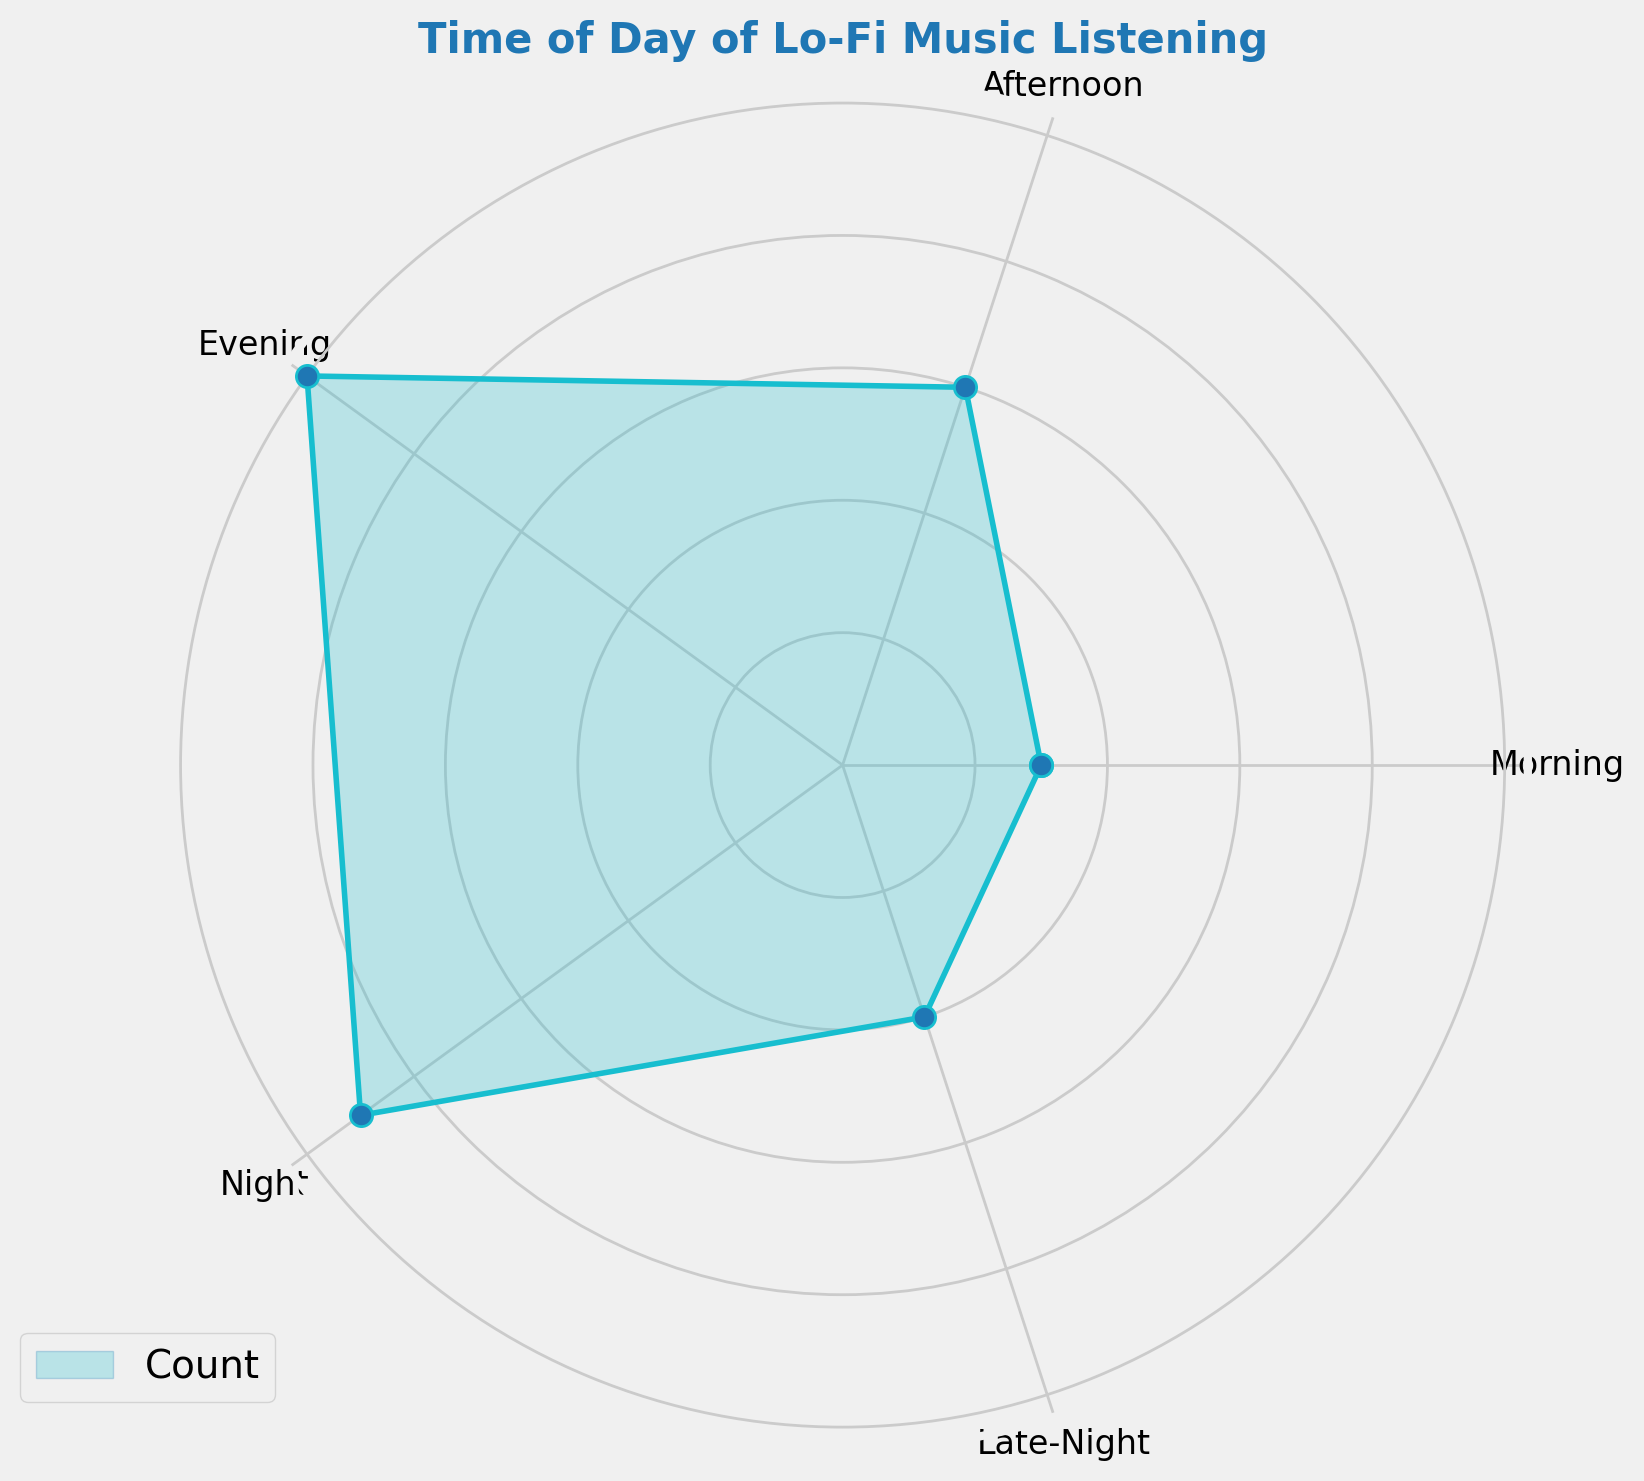What time of day has the highest count of lo-fi music listening? To determine this, observe the radar chart and note where the value reaches its highest point. The highest count is where the data point is farthest from the center. In this case, it's during the Evening.
Answer: Evening Which two time periods have similar listening counts? Look for time periods where the data points are at similar distances from the center. In this case, the Night and Evening sections both have high counts, with Night having a slightly lower count than Evening.
Answer: Night and Evening What is the total count of lo-fi music listening during Morning and Late-Night combined? Add up the counts for Morning and Late-Night. The Morning count is 150 and Late-Night is 200. So, 150 + 200 = 350.
Answer: 350 What is the difference in the count of lo-fi music listening between Afternoon and Night? Subtract the count for Afternoon from the count for Night. Afternoon is 300 and Night is 450. So, 450 - 300 = 150.
Answer: 150 How does the listening count in the Morning compare to that in the Late-Night? Compare the distances from the center for Morning and Late-Night. Morning (150) is shorter than Late-Night (200).
Answer: Morning < Late-Night Which period has the second lowest count of lo-fi music listening? Identify the second smallest value among the displayed counts. The lowest is Morning at 150, and the second lowest is Late-Night at 200.
Answer: Late-Night What is the average count of lo-fi music listening across all time periods? Add up the counts for all periods and divide by the number of periods. The total count is 150 + 300 + 500 + 450 + 200 = 1600. There are 5 periods. So, 1600 / 5 = 320.
Answer: 320 What proportion of the total lo-fi music listening is done in the Evening? Calculate the percentage of the total that the Evening represents. The Evening count is 500, and the total is 1600. So, (500 / 1600) * 100 = 31.25%.
Answer: 31.25% How much higher is Evening listening compared to Morning in terms of count? Subtract the Morning count from the Evening count. Evening is 500 and Morning is 150. So, 500 - 150 = 350.
Answer: 350 